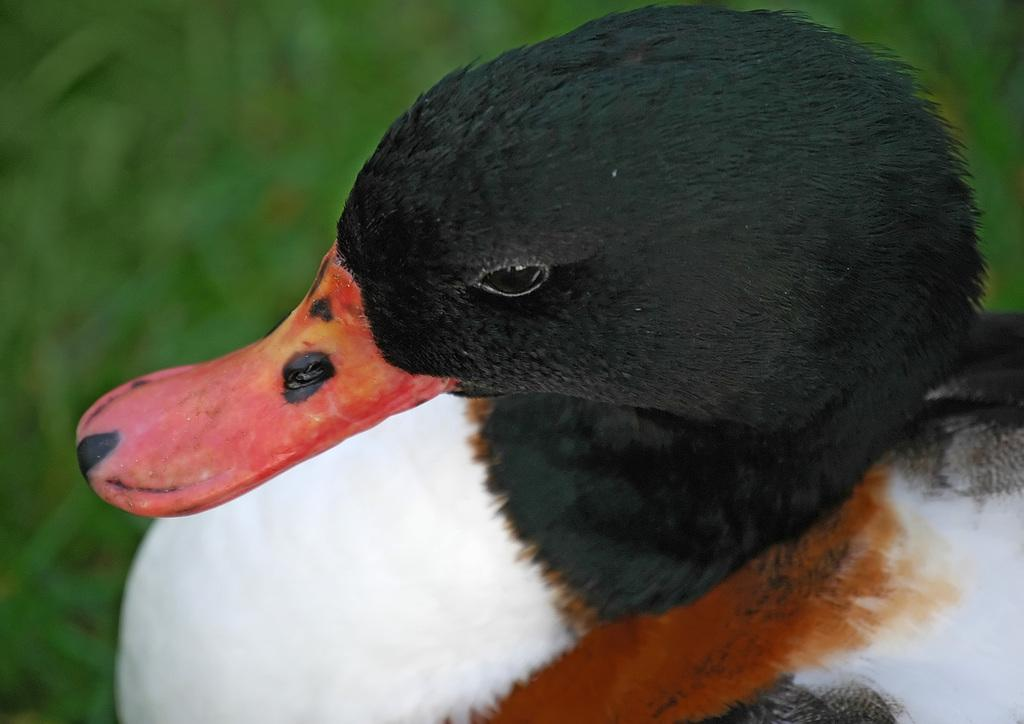What animal is present in the image? There is a duck in the image. Can you describe the background of the image? The background of the image is blurred. What type of reaction can be seen from the vase in the image? There is no vase present in the image, so it is not possible to determine any reaction from it. 